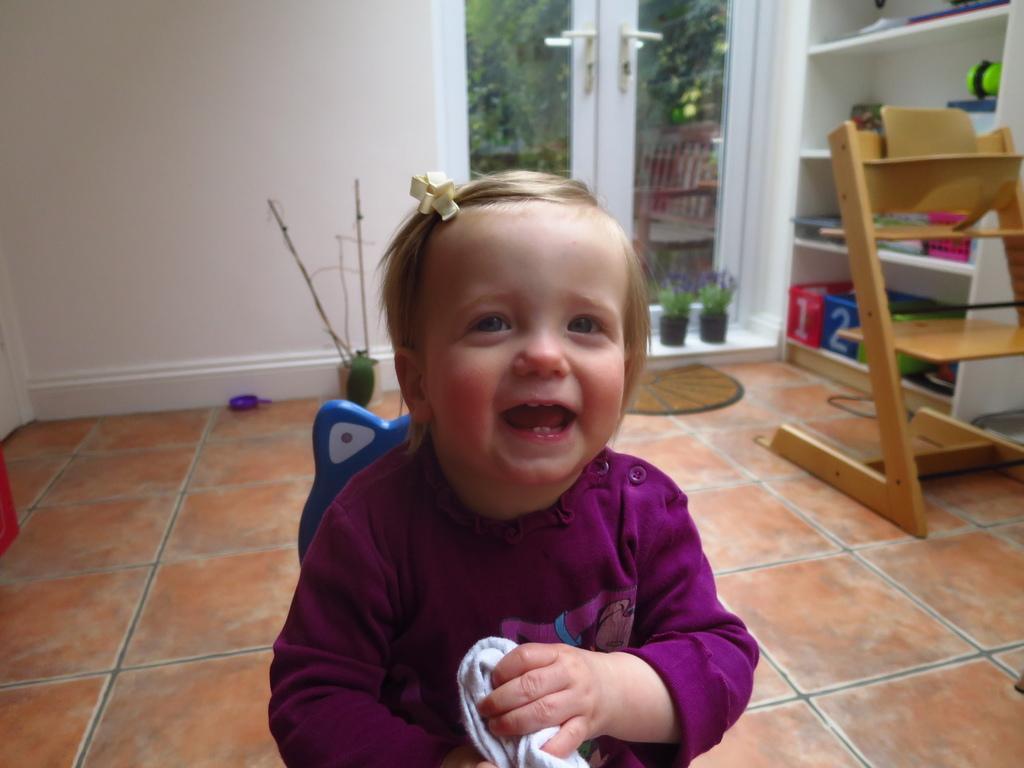How would you summarize this image in a sentence or two? In this image, I can see a small girl smiling. This looks like a wooden object. These are the flower pots. I can see a doormat, which is placed on the floor. This is a door with a door handle. This looks like a rock with the objects in it. I can see the trees and a bench through the glass door. 